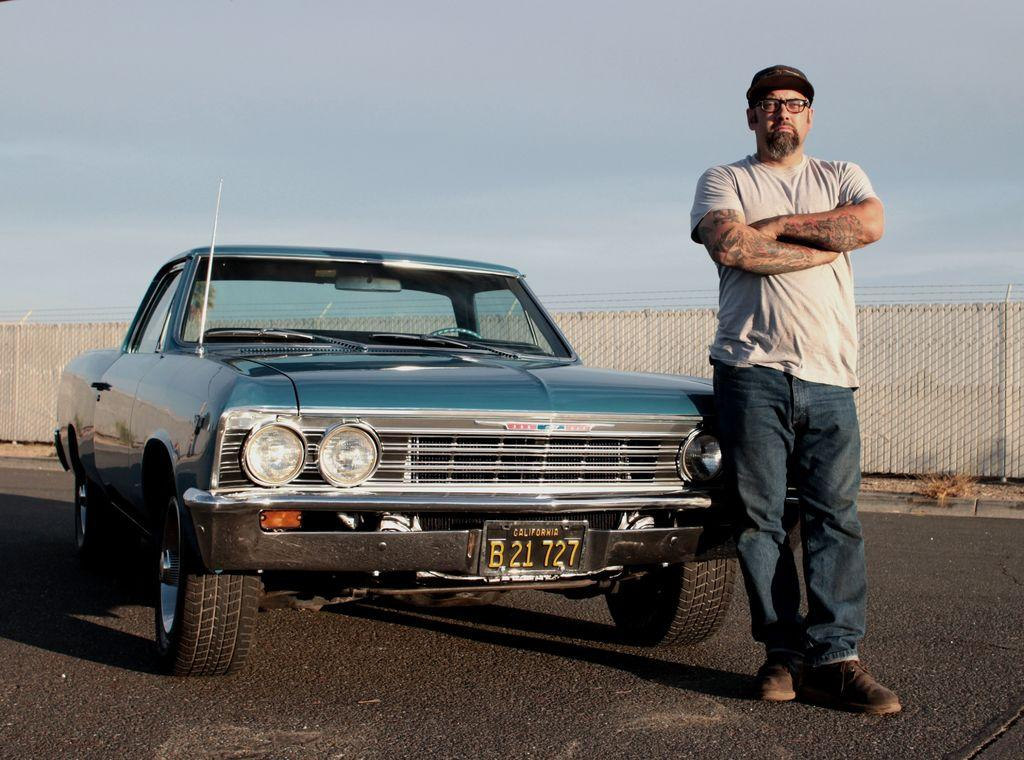What is on the road in the image? There is a vehicle on the road in the image. Who is present in the image besides the vehicle? There is a man in the image. What can be observed about the man's appearance? The man is wearing glasses and a cap. What is visible in the background of the image? There is a fence in the background of the image. What is visible at the top of the image? The sky is visible at the top of the image. What type of pencil is the man using to draw in the image? There is no pencil present in the image; the man is not drawing. What type of oil can be seen dripping from the vehicle in the image? There is no oil dripping from the vehicle in the image. 